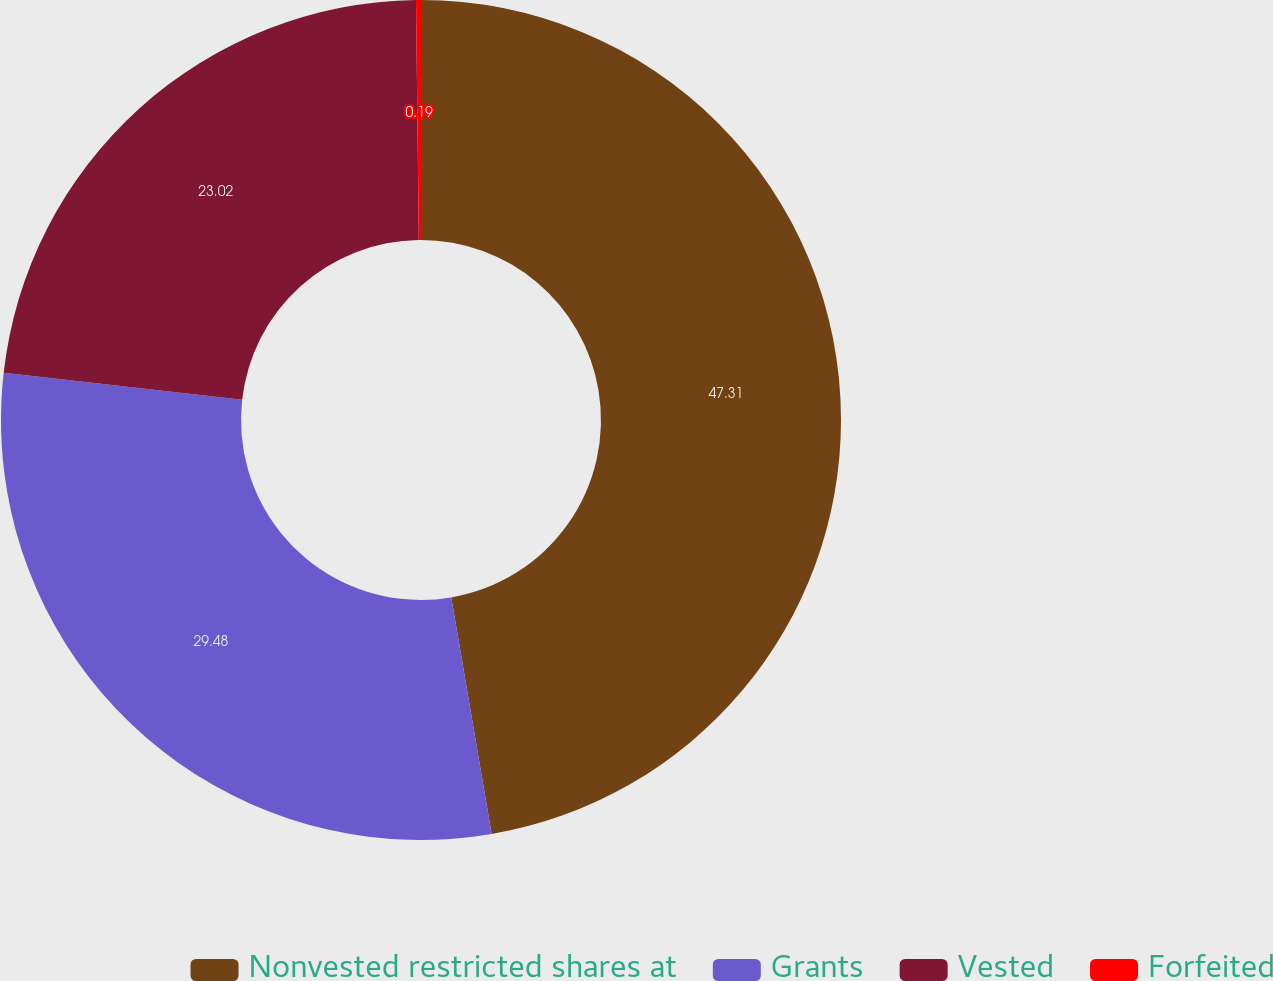Convert chart. <chart><loc_0><loc_0><loc_500><loc_500><pie_chart><fcel>Nonvested restricted shares at<fcel>Grants<fcel>Vested<fcel>Forfeited<nl><fcel>47.31%<fcel>29.48%<fcel>23.02%<fcel>0.19%<nl></chart> 